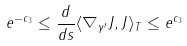<formula> <loc_0><loc_0><loc_500><loc_500>e ^ { - c _ { 3 } } \leq \frac { d } { d s } \langle \nabla _ { \gamma ^ { \prime } } J , J \rangle _ { T } \leq e ^ { c _ { 3 } }</formula> 